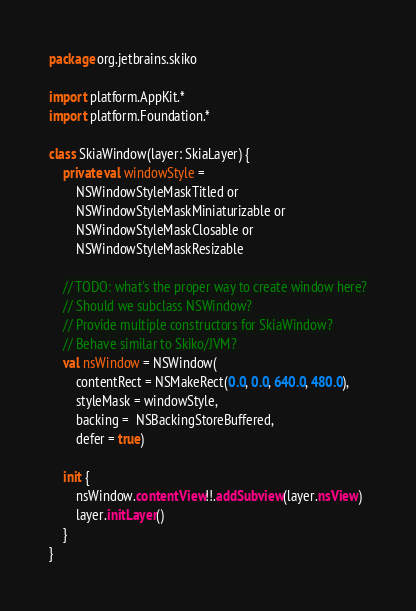<code> <loc_0><loc_0><loc_500><loc_500><_Kotlin_>package org.jetbrains.skiko

import platform.AppKit.*
import platform.Foundation.*

class SkiaWindow(layer: SkiaLayer) {
    private val windowStyle =
        NSWindowStyleMaskTitled or
        NSWindowStyleMaskMiniaturizable or
        NSWindowStyleMaskClosable or
        NSWindowStyleMaskResizable

    // TODO: what's the proper way to create window here?
    // Should we subclass NSWindow?
    // Provide multiple constructors for SkiaWindow?
    // Behave similar to Skiko/JVM?
    val nsWindow = NSWindow(
        contentRect = NSMakeRect(0.0, 0.0, 640.0, 480.0),
        styleMask = windowStyle,
        backing =  NSBackingStoreBuffered,
        defer = true)

    init {
        nsWindow.contentView!!.addSubview(layer.nsView)
        layer.initLayer()
    }
}
</code> 